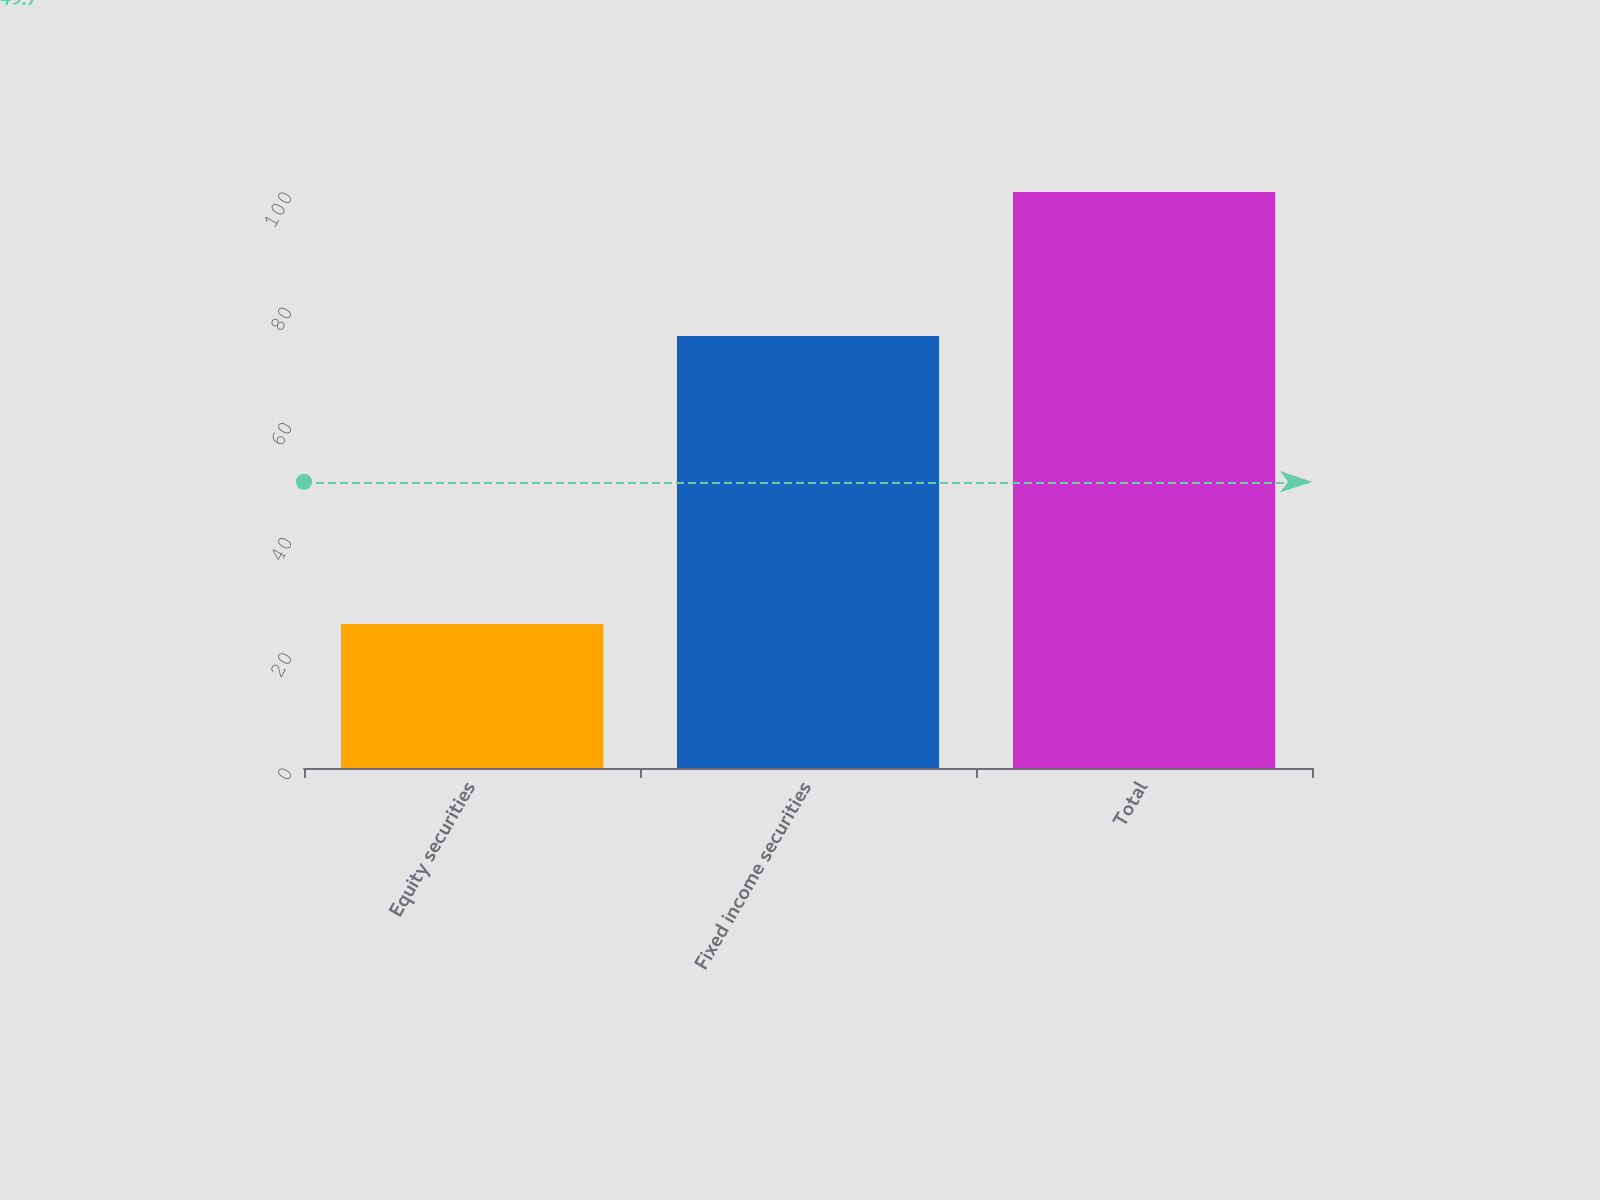Convert chart. <chart><loc_0><loc_0><loc_500><loc_500><bar_chart><fcel>Equity securities<fcel>Fixed income securities<fcel>Total<nl><fcel>25<fcel>75<fcel>100<nl></chart> 